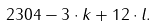Convert formula to latex. <formula><loc_0><loc_0><loc_500><loc_500>2 3 0 4 - 3 \cdot k + 1 2 \cdot l .</formula> 